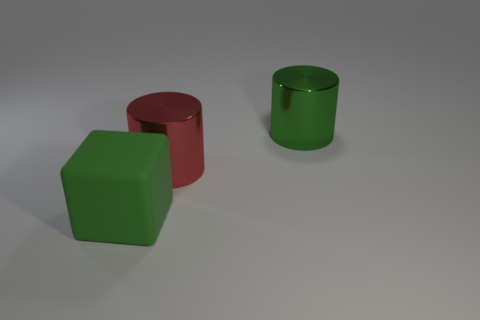Add 3 gray cylinders. How many objects exist? 6 Subtract all cylinders. How many objects are left? 1 Subtract 0 brown cubes. How many objects are left? 3 Subtract all metallic balls. Subtract all large green shiny things. How many objects are left? 2 Add 2 matte blocks. How many matte blocks are left? 3 Add 1 tiny yellow things. How many tiny yellow things exist? 1 